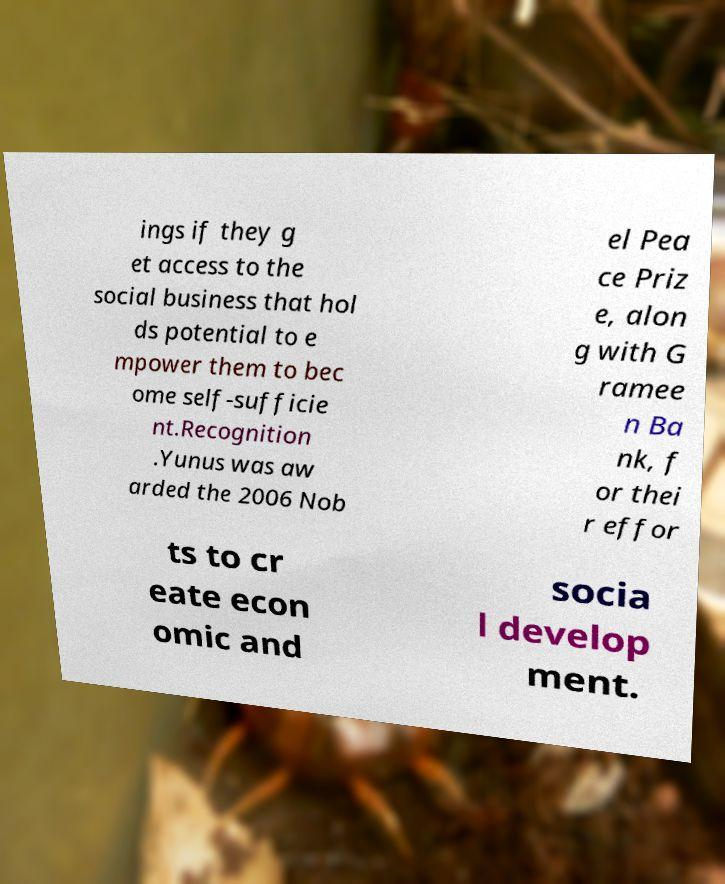For documentation purposes, I need the text within this image transcribed. Could you provide that? ings if they g et access to the social business that hol ds potential to e mpower them to bec ome self-sufficie nt.Recognition .Yunus was aw arded the 2006 Nob el Pea ce Priz e, alon g with G ramee n Ba nk, f or thei r effor ts to cr eate econ omic and socia l develop ment. 